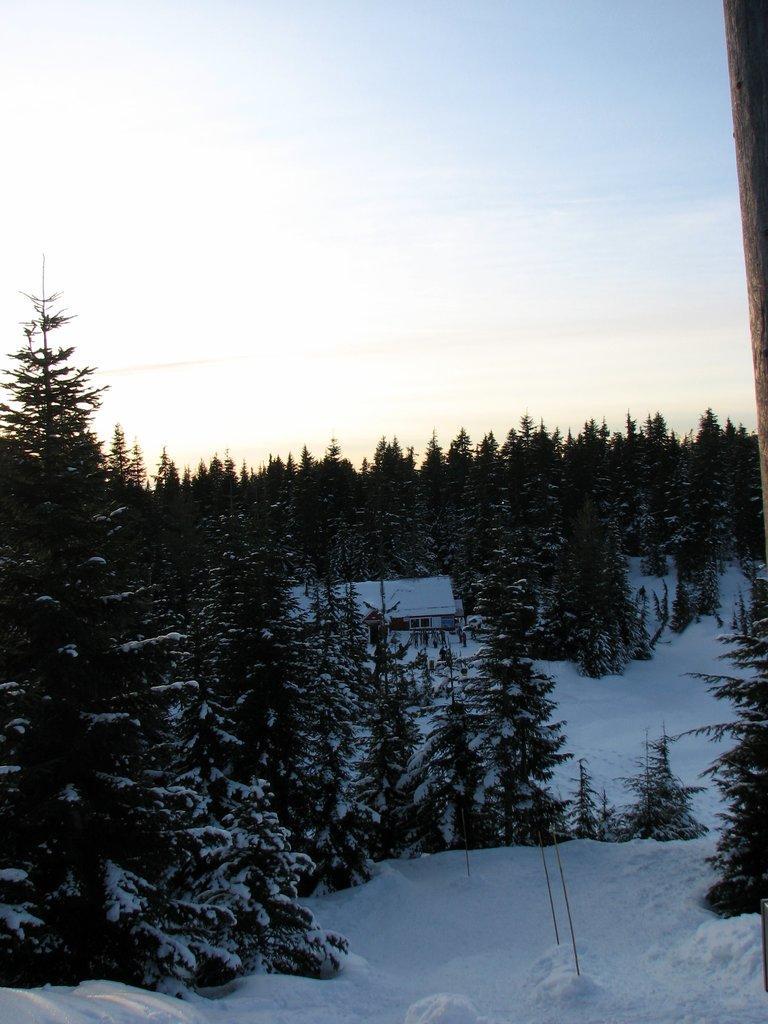Could you give a brief overview of what you see in this image? This image is taken outdoors. At the top of the image there is the sky with clouds. At the bottom of the image there is a ground and it is covered with snow. In the middle of the image there are many trees and plants covered with snow. 